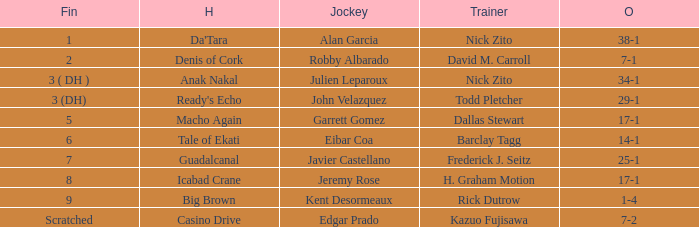Which Horse finished in 8? Icabad Crane. 